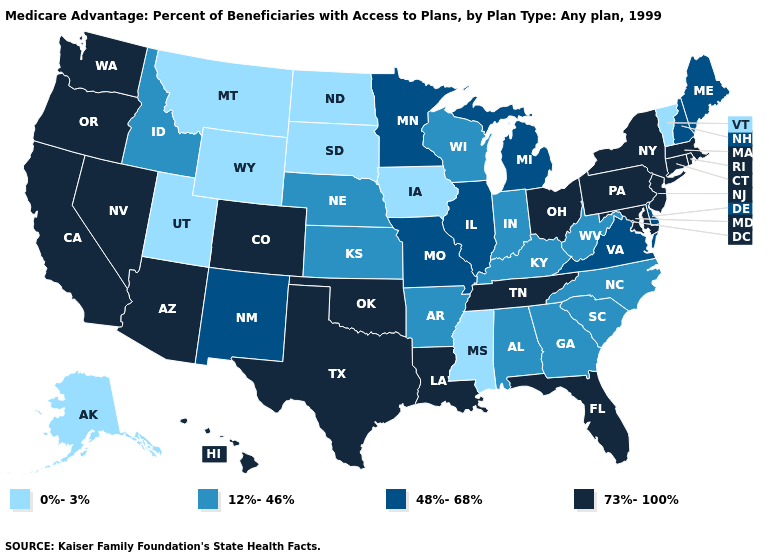Does the first symbol in the legend represent the smallest category?
Write a very short answer. Yes. What is the value of Wisconsin?
Give a very brief answer. 12%-46%. Which states have the lowest value in the USA?
Be succinct. Alaska, Iowa, Mississippi, Montana, North Dakota, South Dakota, Utah, Vermont, Wyoming. Does South Dakota have the highest value in the MidWest?
Answer briefly. No. What is the value of Kansas?
Write a very short answer. 12%-46%. Does Maine have the lowest value in the USA?
Be succinct. No. Among the states that border Virginia , which have the lowest value?
Give a very brief answer. Kentucky, North Carolina, West Virginia. Does the map have missing data?
Answer briefly. No. What is the lowest value in the MidWest?
Be succinct. 0%-3%. Name the states that have a value in the range 73%-100%?
Quick response, please. Arizona, California, Colorado, Connecticut, Florida, Hawaii, Louisiana, Massachusetts, Maryland, New Jersey, Nevada, New York, Ohio, Oklahoma, Oregon, Pennsylvania, Rhode Island, Tennessee, Texas, Washington. What is the value of Nebraska?
Be succinct. 12%-46%. Among the states that border New Mexico , which have the lowest value?
Concise answer only. Utah. Name the states that have a value in the range 48%-68%?
Quick response, please. Delaware, Illinois, Maine, Michigan, Minnesota, Missouri, New Hampshire, New Mexico, Virginia. What is the value of Arkansas?
Write a very short answer. 12%-46%. Among the states that border North Dakota , which have the highest value?
Write a very short answer. Minnesota. 